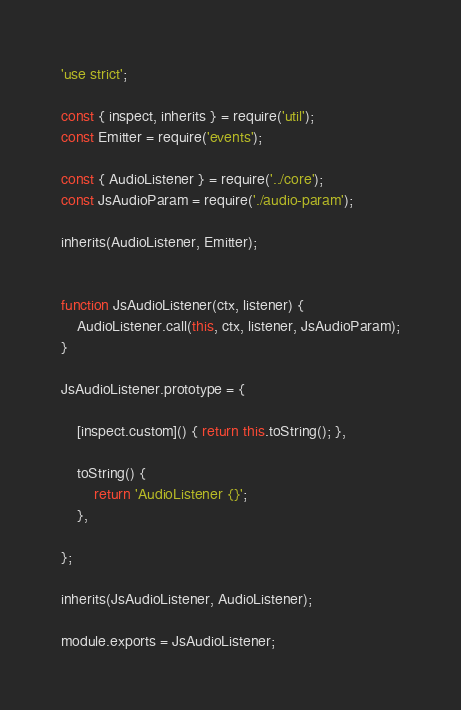Convert code to text. <code><loc_0><loc_0><loc_500><loc_500><_JavaScript_>'use strict';

const { inspect, inherits } = require('util');
const Emitter = require('events');

const { AudioListener } = require('../core');
const JsAudioParam = require('./audio-param');

inherits(AudioListener, Emitter);


function JsAudioListener(ctx, listener) {
	AudioListener.call(this, ctx, listener, JsAudioParam);
}

JsAudioListener.prototype = {
	
	[inspect.custom]() { return this.toString(); },
	
	toString() {
		return 'AudioListener {}';
	},
	
};

inherits(JsAudioListener, AudioListener);

module.exports = JsAudioListener;
</code> 